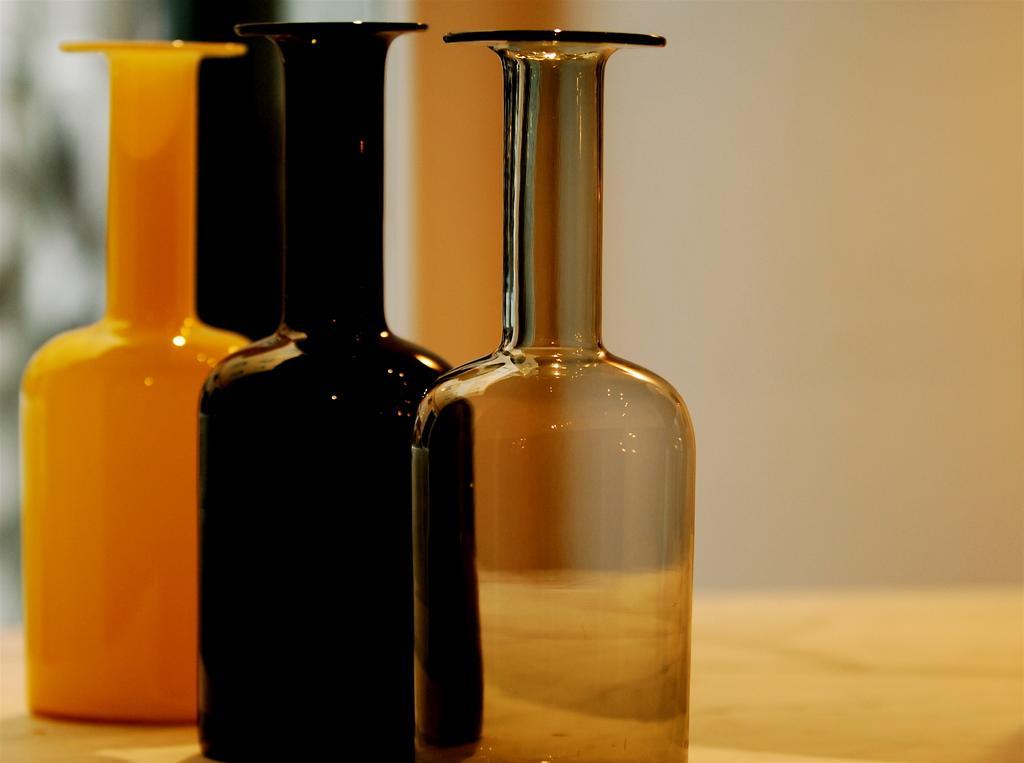Describe this image in one or two sentences. There are three bottles on the table and this is wall. 